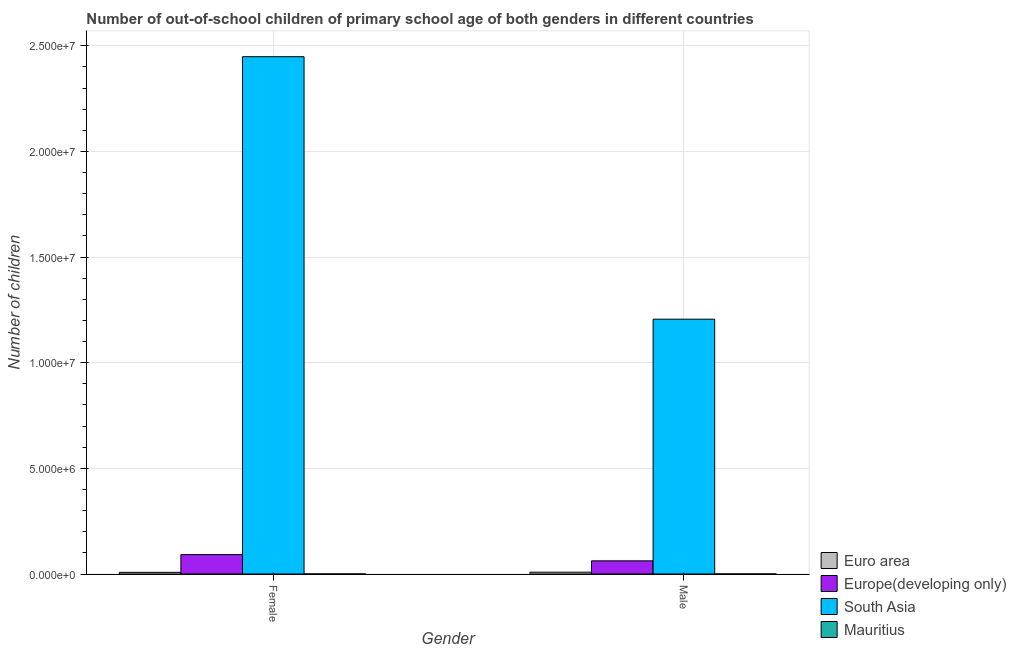How many different coloured bars are there?
Offer a terse response. 4. How many bars are there on the 2nd tick from the left?
Your answer should be compact. 4. What is the number of female out-of-school students in Europe(developing only)?
Provide a succinct answer. 9.17e+05. Across all countries, what is the maximum number of male out-of-school students?
Your response must be concise. 1.21e+07. Across all countries, what is the minimum number of female out-of-school students?
Your response must be concise. 2390. In which country was the number of female out-of-school students minimum?
Your response must be concise. Mauritius. What is the total number of male out-of-school students in the graph?
Give a very brief answer. 1.28e+07. What is the difference between the number of female out-of-school students in South Asia and that in Euro area?
Your answer should be very brief. 2.44e+07. What is the difference between the number of male out-of-school students in Europe(developing only) and the number of female out-of-school students in South Asia?
Ensure brevity in your answer.  -2.39e+07. What is the average number of male out-of-school students per country?
Your response must be concise. 3.19e+06. What is the difference between the number of female out-of-school students and number of male out-of-school students in Euro area?
Your answer should be compact. -6603. What is the ratio of the number of male out-of-school students in Euro area to that in South Asia?
Ensure brevity in your answer.  0.01. Is the number of female out-of-school students in Europe(developing only) less than that in Mauritius?
Ensure brevity in your answer.  No. What does the 1st bar from the left in Male represents?
Provide a short and direct response. Euro area. How many bars are there?
Provide a succinct answer. 8. Are the values on the major ticks of Y-axis written in scientific E-notation?
Give a very brief answer. Yes. Where does the legend appear in the graph?
Your answer should be compact. Bottom right. How are the legend labels stacked?
Give a very brief answer. Vertical. What is the title of the graph?
Provide a short and direct response. Number of out-of-school children of primary school age of both genders in different countries. Does "France" appear as one of the legend labels in the graph?
Make the answer very short. No. What is the label or title of the Y-axis?
Give a very brief answer. Number of children. What is the Number of children in Euro area in Female?
Provide a short and direct response. 7.88e+04. What is the Number of children in Europe(developing only) in Female?
Offer a very short reply. 9.17e+05. What is the Number of children of South Asia in Female?
Your answer should be very brief. 2.45e+07. What is the Number of children of Mauritius in Female?
Offer a very short reply. 2390. What is the Number of children in Euro area in Male?
Your answer should be compact. 8.54e+04. What is the Number of children of Europe(developing only) in Male?
Give a very brief answer. 6.23e+05. What is the Number of children in South Asia in Male?
Provide a short and direct response. 1.21e+07. What is the Number of children in Mauritius in Male?
Your answer should be compact. 2683. Across all Gender, what is the maximum Number of children of Euro area?
Ensure brevity in your answer.  8.54e+04. Across all Gender, what is the maximum Number of children in Europe(developing only)?
Give a very brief answer. 9.17e+05. Across all Gender, what is the maximum Number of children in South Asia?
Offer a terse response. 2.45e+07. Across all Gender, what is the maximum Number of children of Mauritius?
Your response must be concise. 2683. Across all Gender, what is the minimum Number of children of Euro area?
Offer a very short reply. 7.88e+04. Across all Gender, what is the minimum Number of children of Europe(developing only)?
Your answer should be compact. 6.23e+05. Across all Gender, what is the minimum Number of children in South Asia?
Make the answer very short. 1.21e+07. Across all Gender, what is the minimum Number of children in Mauritius?
Offer a very short reply. 2390. What is the total Number of children in Euro area in the graph?
Provide a succinct answer. 1.64e+05. What is the total Number of children of Europe(developing only) in the graph?
Offer a terse response. 1.54e+06. What is the total Number of children in South Asia in the graph?
Your answer should be compact. 3.65e+07. What is the total Number of children of Mauritius in the graph?
Your response must be concise. 5073. What is the difference between the Number of children of Euro area in Female and that in Male?
Your answer should be very brief. -6603. What is the difference between the Number of children in Europe(developing only) in Female and that in Male?
Make the answer very short. 2.94e+05. What is the difference between the Number of children of South Asia in Female and that in Male?
Provide a succinct answer. 1.24e+07. What is the difference between the Number of children in Mauritius in Female and that in Male?
Your response must be concise. -293. What is the difference between the Number of children of Euro area in Female and the Number of children of Europe(developing only) in Male?
Provide a short and direct response. -5.44e+05. What is the difference between the Number of children in Euro area in Female and the Number of children in South Asia in Male?
Your answer should be very brief. -1.20e+07. What is the difference between the Number of children of Euro area in Female and the Number of children of Mauritius in Male?
Make the answer very short. 7.61e+04. What is the difference between the Number of children of Europe(developing only) in Female and the Number of children of South Asia in Male?
Your answer should be very brief. -1.11e+07. What is the difference between the Number of children of Europe(developing only) in Female and the Number of children of Mauritius in Male?
Ensure brevity in your answer.  9.15e+05. What is the difference between the Number of children of South Asia in Female and the Number of children of Mauritius in Male?
Your answer should be compact. 2.45e+07. What is the average Number of children of Euro area per Gender?
Your answer should be compact. 8.21e+04. What is the average Number of children of Europe(developing only) per Gender?
Ensure brevity in your answer.  7.70e+05. What is the average Number of children of South Asia per Gender?
Provide a succinct answer. 1.83e+07. What is the average Number of children of Mauritius per Gender?
Your response must be concise. 2536.5. What is the difference between the Number of children of Euro area and Number of children of Europe(developing only) in Female?
Your answer should be very brief. -8.39e+05. What is the difference between the Number of children of Euro area and Number of children of South Asia in Female?
Your answer should be compact. -2.44e+07. What is the difference between the Number of children in Euro area and Number of children in Mauritius in Female?
Offer a very short reply. 7.64e+04. What is the difference between the Number of children of Europe(developing only) and Number of children of South Asia in Female?
Your response must be concise. -2.36e+07. What is the difference between the Number of children of Europe(developing only) and Number of children of Mauritius in Female?
Give a very brief answer. 9.15e+05. What is the difference between the Number of children in South Asia and Number of children in Mauritius in Female?
Your answer should be very brief. 2.45e+07. What is the difference between the Number of children of Euro area and Number of children of Europe(developing only) in Male?
Give a very brief answer. -5.38e+05. What is the difference between the Number of children in Euro area and Number of children in South Asia in Male?
Offer a terse response. -1.20e+07. What is the difference between the Number of children of Euro area and Number of children of Mauritius in Male?
Ensure brevity in your answer.  8.27e+04. What is the difference between the Number of children in Europe(developing only) and Number of children in South Asia in Male?
Offer a very short reply. -1.14e+07. What is the difference between the Number of children of Europe(developing only) and Number of children of Mauritius in Male?
Keep it short and to the point. 6.20e+05. What is the difference between the Number of children of South Asia and Number of children of Mauritius in Male?
Your answer should be compact. 1.21e+07. What is the ratio of the Number of children in Euro area in Female to that in Male?
Ensure brevity in your answer.  0.92. What is the ratio of the Number of children in Europe(developing only) in Female to that in Male?
Offer a very short reply. 1.47. What is the ratio of the Number of children in South Asia in Female to that in Male?
Ensure brevity in your answer.  2.03. What is the ratio of the Number of children of Mauritius in Female to that in Male?
Give a very brief answer. 0.89. What is the difference between the highest and the second highest Number of children of Euro area?
Provide a short and direct response. 6603. What is the difference between the highest and the second highest Number of children of Europe(developing only)?
Your answer should be very brief. 2.94e+05. What is the difference between the highest and the second highest Number of children of South Asia?
Give a very brief answer. 1.24e+07. What is the difference between the highest and the second highest Number of children of Mauritius?
Offer a very short reply. 293. What is the difference between the highest and the lowest Number of children of Euro area?
Keep it short and to the point. 6603. What is the difference between the highest and the lowest Number of children in Europe(developing only)?
Make the answer very short. 2.94e+05. What is the difference between the highest and the lowest Number of children in South Asia?
Give a very brief answer. 1.24e+07. What is the difference between the highest and the lowest Number of children in Mauritius?
Your answer should be compact. 293. 